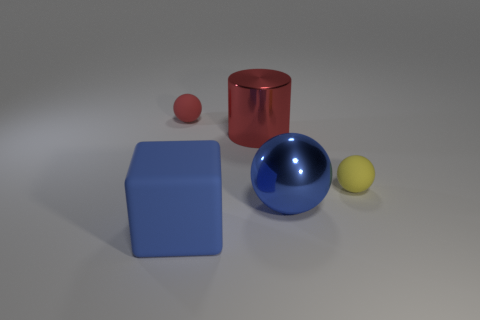Add 2 metal balls. How many objects exist? 7 Subtract all blocks. How many objects are left? 4 Add 2 large blue metallic things. How many large blue metallic things are left? 3 Add 4 large shiny things. How many large shiny things exist? 6 Subtract all yellow balls. How many balls are left? 2 Subtract all blue metal balls. How many balls are left? 2 Subtract 0 cyan cylinders. How many objects are left? 5 Subtract 3 spheres. How many spheres are left? 0 Subtract all brown spheres. Subtract all gray cylinders. How many spheres are left? 3 Subtract all blue cylinders. How many red spheres are left? 1 